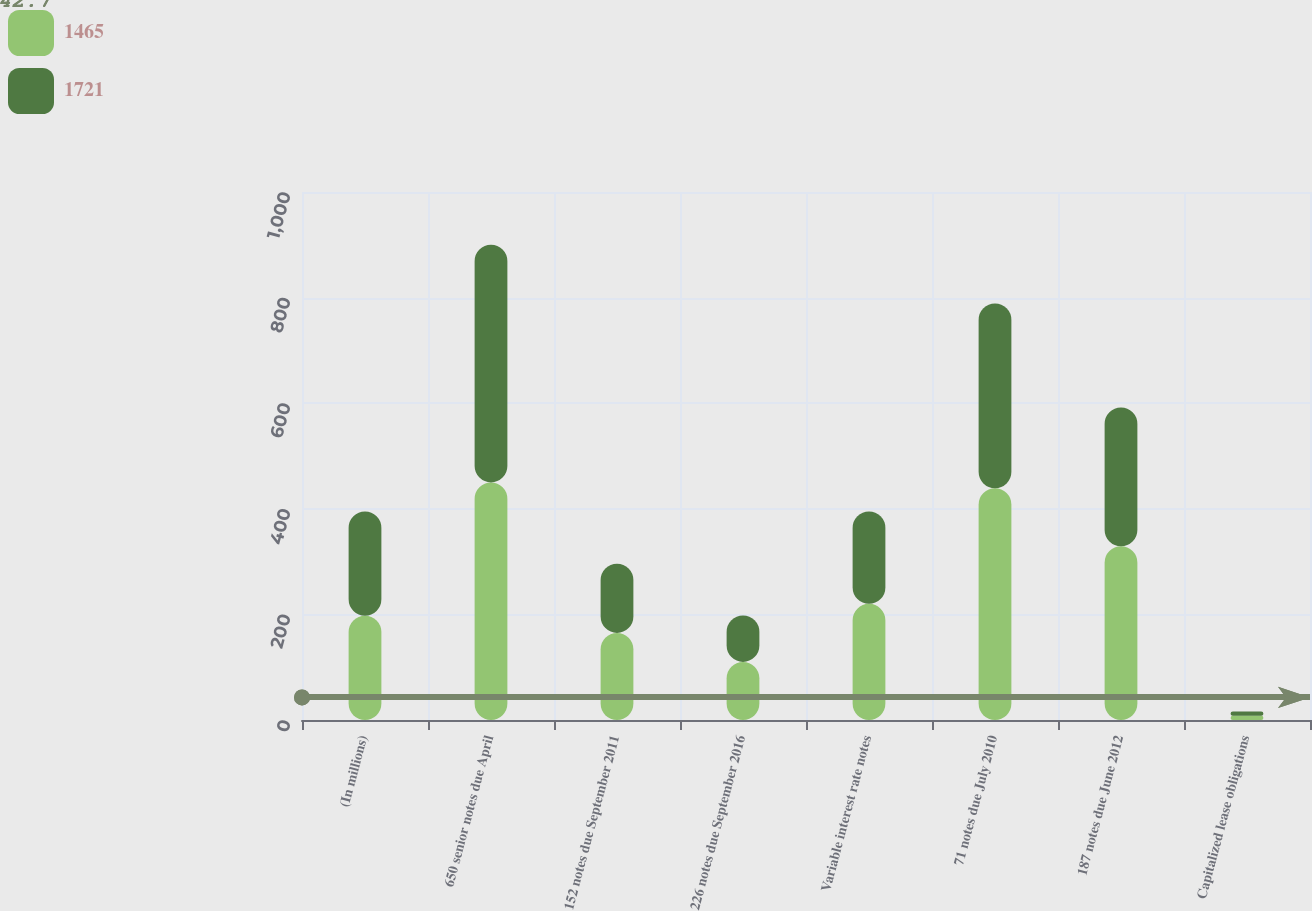Convert chart. <chart><loc_0><loc_0><loc_500><loc_500><stacked_bar_chart><ecel><fcel>(In millions)<fcel>650 senior notes due April<fcel>152 notes due September 2011<fcel>226 notes due September 2016<fcel>Variable interest rate notes<fcel>71 notes due July 2010<fcel>187 notes due June 2012<fcel>Capitalized lease obligations<nl><fcel>1465<fcel>197.5<fcel>450<fcel>165<fcel>110<fcel>220<fcel>439<fcel>329<fcel>8<nl><fcel>1721<fcel>197.5<fcel>450<fcel>131<fcel>88<fcel>175<fcel>350<fcel>263<fcel>8<nl></chart> 